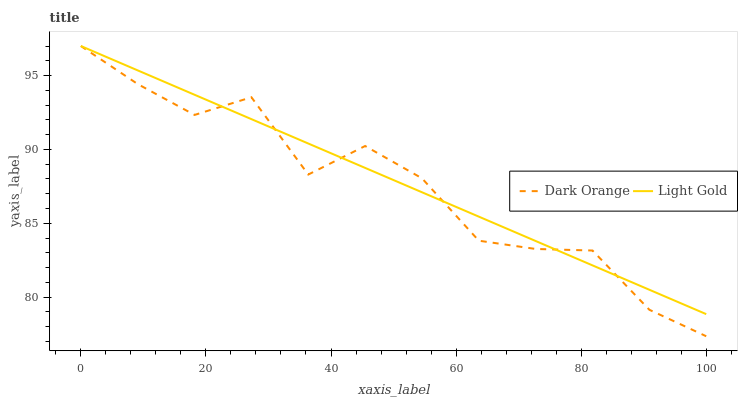Does Dark Orange have the minimum area under the curve?
Answer yes or no. Yes. Does Light Gold have the maximum area under the curve?
Answer yes or no. Yes. Does Light Gold have the minimum area under the curve?
Answer yes or no. No. Is Light Gold the smoothest?
Answer yes or no. Yes. Is Dark Orange the roughest?
Answer yes or no. Yes. Is Light Gold the roughest?
Answer yes or no. No. Does Dark Orange have the lowest value?
Answer yes or no. Yes. Does Light Gold have the lowest value?
Answer yes or no. No. Does Light Gold have the highest value?
Answer yes or no. Yes. Does Light Gold intersect Dark Orange?
Answer yes or no. Yes. Is Light Gold less than Dark Orange?
Answer yes or no. No. Is Light Gold greater than Dark Orange?
Answer yes or no. No. 